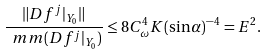Convert formula to latex. <formula><loc_0><loc_0><loc_500><loc_500>\frac { \| D f ^ { j } | _ { Y _ { 0 } } \| } { \ m m ( D f ^ { j } | _ { Y _ { 0 } } ) } \leq 8 C _ { \omega } ^ { 4 } K ( \sin \alpha ) ^ { - 4 } = E ^ { 2 } .</formula> 